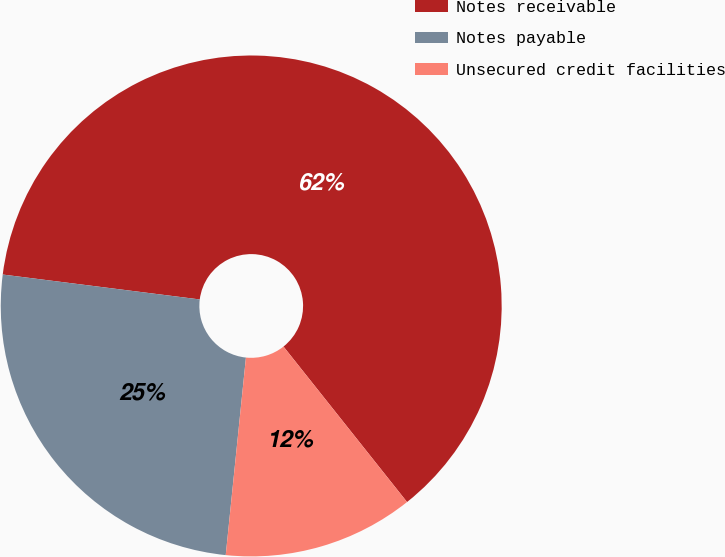Convert chart to OTSL. <chart><loc_0><loc_0><loc_500><loc_500><pie_chart><fcel>Notes receivable<fcel>Notes payable<fcel>Unsecured credit facilities<nl><fcel>62.31%<fcel>25.38%<fcel>12.31%<nl></chart> 